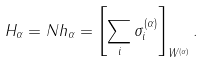<formula> <loc_0><loc_0><loc_500><loc_500>H _ { \alpha } = N h _ { \alpha } = \left [ \sum _ { i } \sigma _ { i } ^ { ( \alpha ) } \right ] _ { W ^ { ( \alpha ) } } .</formula> 